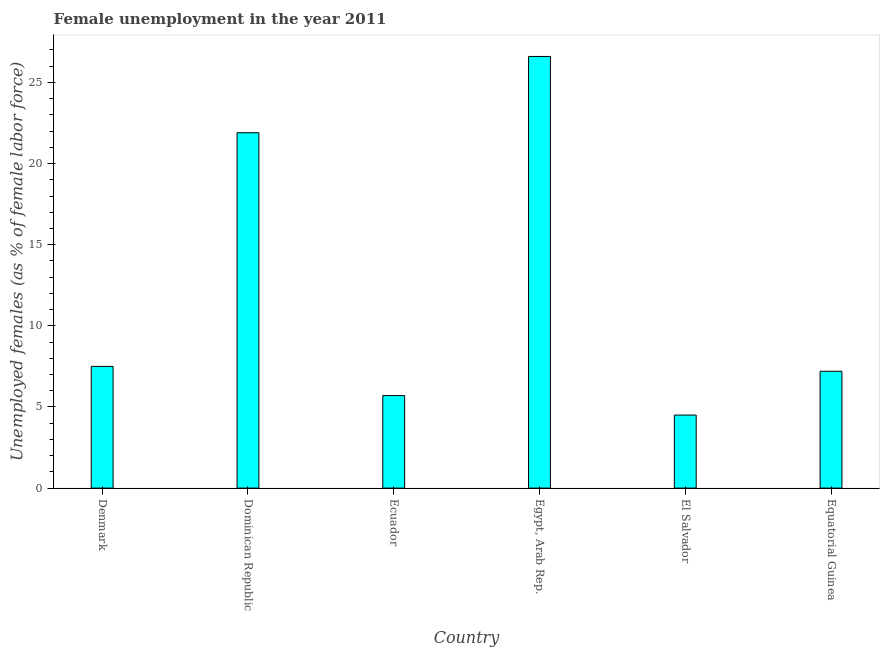What is the title of the graph?
Give a very brief answer. Female unemployment in the year 2011. What is the label or title of the X-axis?
Ensure brevity in your answer.  Country. What is the label or title of the Y-axis?
Provide a short and direct response. Unemployed females (as % of female labor force). What is the unemployed females population in Equatorial Guinea?
Ensure brevity in your answer.  7.2. Across all countries, what is the maximum unemployed females population?
Provide a succinct answer. 26.6. Across all countries, what is the minimum unemployed females population?
Provide a short and direct response. 4.5. In which country was the unemployed females population maximum?
Ensure brevity in your answer.  Egypt, Arab Rep. In which country was the unemployed females population minimum?
Ensure brevity in your answer.  El Salvador. What is the sum of the unemployed females population?
Your answer should be very brief. 73.4. What is the average unemployed females population per country?
Offer a very short reply. 12.23. What is the median unemployed females population?
Make the answer very short. 7.35. In how many countries, is the unemployed females population greater than 3 %?
Ensure brevity in your answer.  6. What is the ratio of the unemployed females population in Dominican Republic to that in Egypt, Arab Rep.?
Provide a short and direct response. 0.82. What is the difference between the highest and the second highest unemployed females population?
Your response must be concise. 4.7. Is the sum of the unemployed females population in Dominican Republic and El Salvador greater than the maximum unemployed females population across all countries?
Ensure brevity in your answer.  No. What is the difference between the highest and the lowest unemployed females population?
Offer a terse response. 22.1. How many bars are there?
Your response must be concise. 6. How many countries are there in the graph?
Offer a terse response. 6. What is the difference between two consecutive major ticks on the Y-axis?
Your answer should be compact. 5. Are the values on the major ticks of Y-axis written in scientific E-notation?
Keep it short and to the point. No. What is the Unemployed females (as % of female labor force) in Denmark?
Provide a succinct answer. 7.5. What is the Unemployed females (as % of female labor force) of Dominican Republic?
Make the answer very short. 21.9. What is the Unemployed females (as % of female labor force) of Ecuador?
Offer a terse response. 5.7. What is the Unemployed females (as % of female labor force) in Egypt, Arab Rep.?
Your response must be concise. 26.6. What is the Unemployed females (as % of female labor force) in El Salvador?
Ensure brevity in your answer.  4.5. What is the Unemployed females (as % of female labor force) of Equatorial Guinea?
Provide a short and direct response. 7.2. What is the difference between the Unemployed females (as % of female labor force) in Denmark and Dominican Republic?
Keep it short and to the point. -14.4. What is the difference between the Unemployed females (as % of female labor force) in Denmark and Egypt, Arab Rep.?
Your response must be concise. -19.1. What is the difference between the Unemployed females (as % of female labor force) in Denmark and Equatorial Guinea?
Ensure brevity in your answer.  0.3. What is the difference between the Unemployed females (as % of female labor force) in Dominican Republic and El Salvador?
Your answer should be compact. 17.4. What is the difference between the Unemployed females (as % of female labor force) in Ecuador and Egypt, Arab Rep.?
Keep it short and to the point. -20.9. What is the difference between the Unemployed females (as % of female labor force) in Ecuador and Equatorial Guinea?
Give a very brief answer. -1.5. What is the difference between the Unemployed females (as % of female labor force) in Egypt, Arab Rep. and El Salvador?
Provide a succinct answer. 22.1. What is the ratio of the Unemployed females (as % of female labor force) in Denmark to that in Dominican Republic?
Offer a very short reply. 0.34. What is the ratio of the Unemployed females (as % of female labor force) in Denmark to that in Ecuador?
Your answer should be compact. 1.32. What is the ratio of the Unemployed females (as % of female labor force) in Denmark to that in Egypt, Arab Rep.?
Offer a very short reply. 0.28. What is the ratio of the Unemployed females (as % of female labor force) in Denmark to that in El Salvador?
Offer a terse response. 1.67. What is the ratio of the Unemployed females (as % of female labor force) in Denmark to that in Equatorial Guinea?
Your response must be concise. 1.04. What is the ratio of the Unemployed females (as % of female labor force) in Dominican Republic to that in Ecuador?
Provide a short and direct response. 3.84. What is the ratio of the Unemployed females (as % of female labor force) in Dominican Republic to that in Egypt, Arab Rep.?
Your answer should be very brief. 0.82. What is the ratio of the Unemployed females (as % of female labor force) in Dominican Republic to that in El Salvador?
Your answer should be compact. 4.87. What is the ratio of the Unemployed females (as % of female labor force) in Dominican Republic to that in Equatorial Guinea?
Ensure brevity in your answer.  3.04. What is the ratio of the Unemployed females (as % of female labor force) in Ecuador to that in Egypt, Arab Rep.?
Your answer should be compact. 0.21. What is the ratio of the Unemployed females (as % of female labor force) in Ecuador to that in El Salvador?
Provide a succinct answer. 1.27. What is the ratio of the Unemployed females (as % of female labor force) in Ecuador to that in Equatorial Guinea?
Keep it short and to the point. 0.79. What is the ratio of the Unemployed females (as % of female labor force) in Egypt, Arab Rep. to that in El Salvador?
Your answer should be compact. 5.91. What is the ratio of the Unemployed females (as % of female labor force) in Egypt, Arab Rep. to that in Equatorial Guinea?
Your response must be concise. 3.69. What is the ratio of the Unemployed females (as % of female labor force) in El Salvador to that in Equatorial Guinea?
Provide a succinct answer. 0.62. 